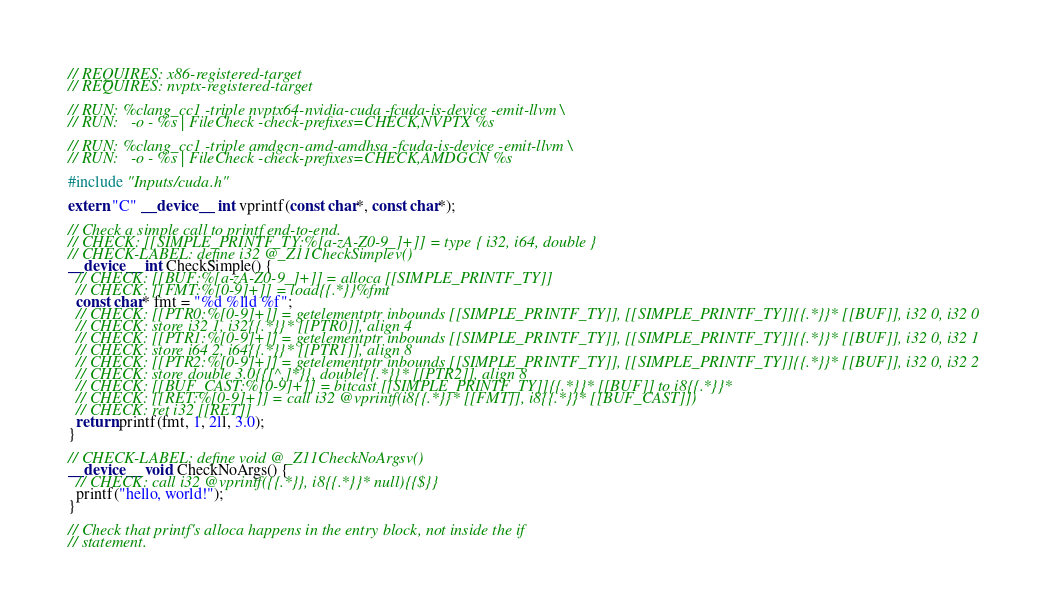Convert code to text. <code><loc_0><loc_0><loc_500><loc_500><_Cuda_>// REQUIRES: x86-registered-target
// REQUIRES: nvptx-registered-target

// RUN: %clang_cc1 -triple nvptx64-nvidia-cuda -fcuda-is-device -emit-llvm \
// RUN:   -o - %s | FileCheck -check-prefixes=CHECK,NVPTX %s

// RUN: %clang_cc1 -triple amdgcn-amd-amdhsa -fcuda-is-device -emit-llvm \
// RUN:   -o - %s | FileCheck -check-prefixes=CHECK,AMDGCN %s

#include "Inputs/cuda.h"

extern "C" __device__ int vprintf(const char*, const char*);

// Check a simple call to printf end-to-end.
// CHECK: [[SIMPLE_PRINTF_TY:%[a-zA-Z0-9_]+]] = type { i32, i64, double }
// CHECK-LABEL: define i32 @_Z11CheckSimplev()
__device__ int CheckSimple() {
  // CHECK: [[BUF:%[a-zA-Z0-9_]+]] = alloca [[SIMPLE_PRINTF_TY]]
  // CHECK: [[FMT:%[0-9]+]] = load{{.*}}%fmt
  const char* fmt = "%d %lld %f";
  // CHECK: [[PTR0:%[0-9]+]] = getelementptr inbounds [[SIMPLE_PRINTF_TY]], [[SIMPLE_PRINTF_TY]]{{.*}}* [[BUF]], i32 0, i32 0
  // CHECK: store i32 1, i32{{.*}}* [[PTR0]], align 4
  // CHECK: [[PTR1:%[0-9]+]] = getelementptr inbounds [[SIMPLE_PRINTF_TY]], [[SIMPLE_PRINTF_TY]]{{.*}}* [[BUF]], i32 0, i32 1
  // CHECK: store i64 2, i64{{.*}}* [[PTR1]], align 8
  // CHECK: [[PTR2:%[0-9]+]] = getelementptr inbounds [[SIMPLE_PRINTF_TY]], [[SIMPLE_PRINTF_TY]]{{.*}}* [[BUF]], i32 0, i32 2
  // CHECK: store double 3.0{{[^,]*}}, double{{.*}}* [[PTR2]], align 8
  // CHECK: [[BUF_CAST:%[0-9]+]] = bitcast [[SIMPLE_PRINTF_TY]]{{.*}}* [[BUF]] to i8{{.*}}*
  // CHECK: [[RET:%[0-9]+]] = call i32 @vprintf(i8{{.*}}* [[FMT]], i8{{.*}}* [[BUF_CAST]])
  // CHECK: ret i32 [[RET]]
  return printf(fmt, 1, 2ll, 3.0);
}

// CHECK-LABEL: define void @_Z11CheckNoArgsv()
__device__ void CheckNoArgs() {
  // CHECK: call i32 @vprintf({{.*}}, i8{{.*}}* null){{$}}
  printf("hello, world!");
}

// Check that printf's alloca happens in the entry block, not inside the if
// statement.</code> 